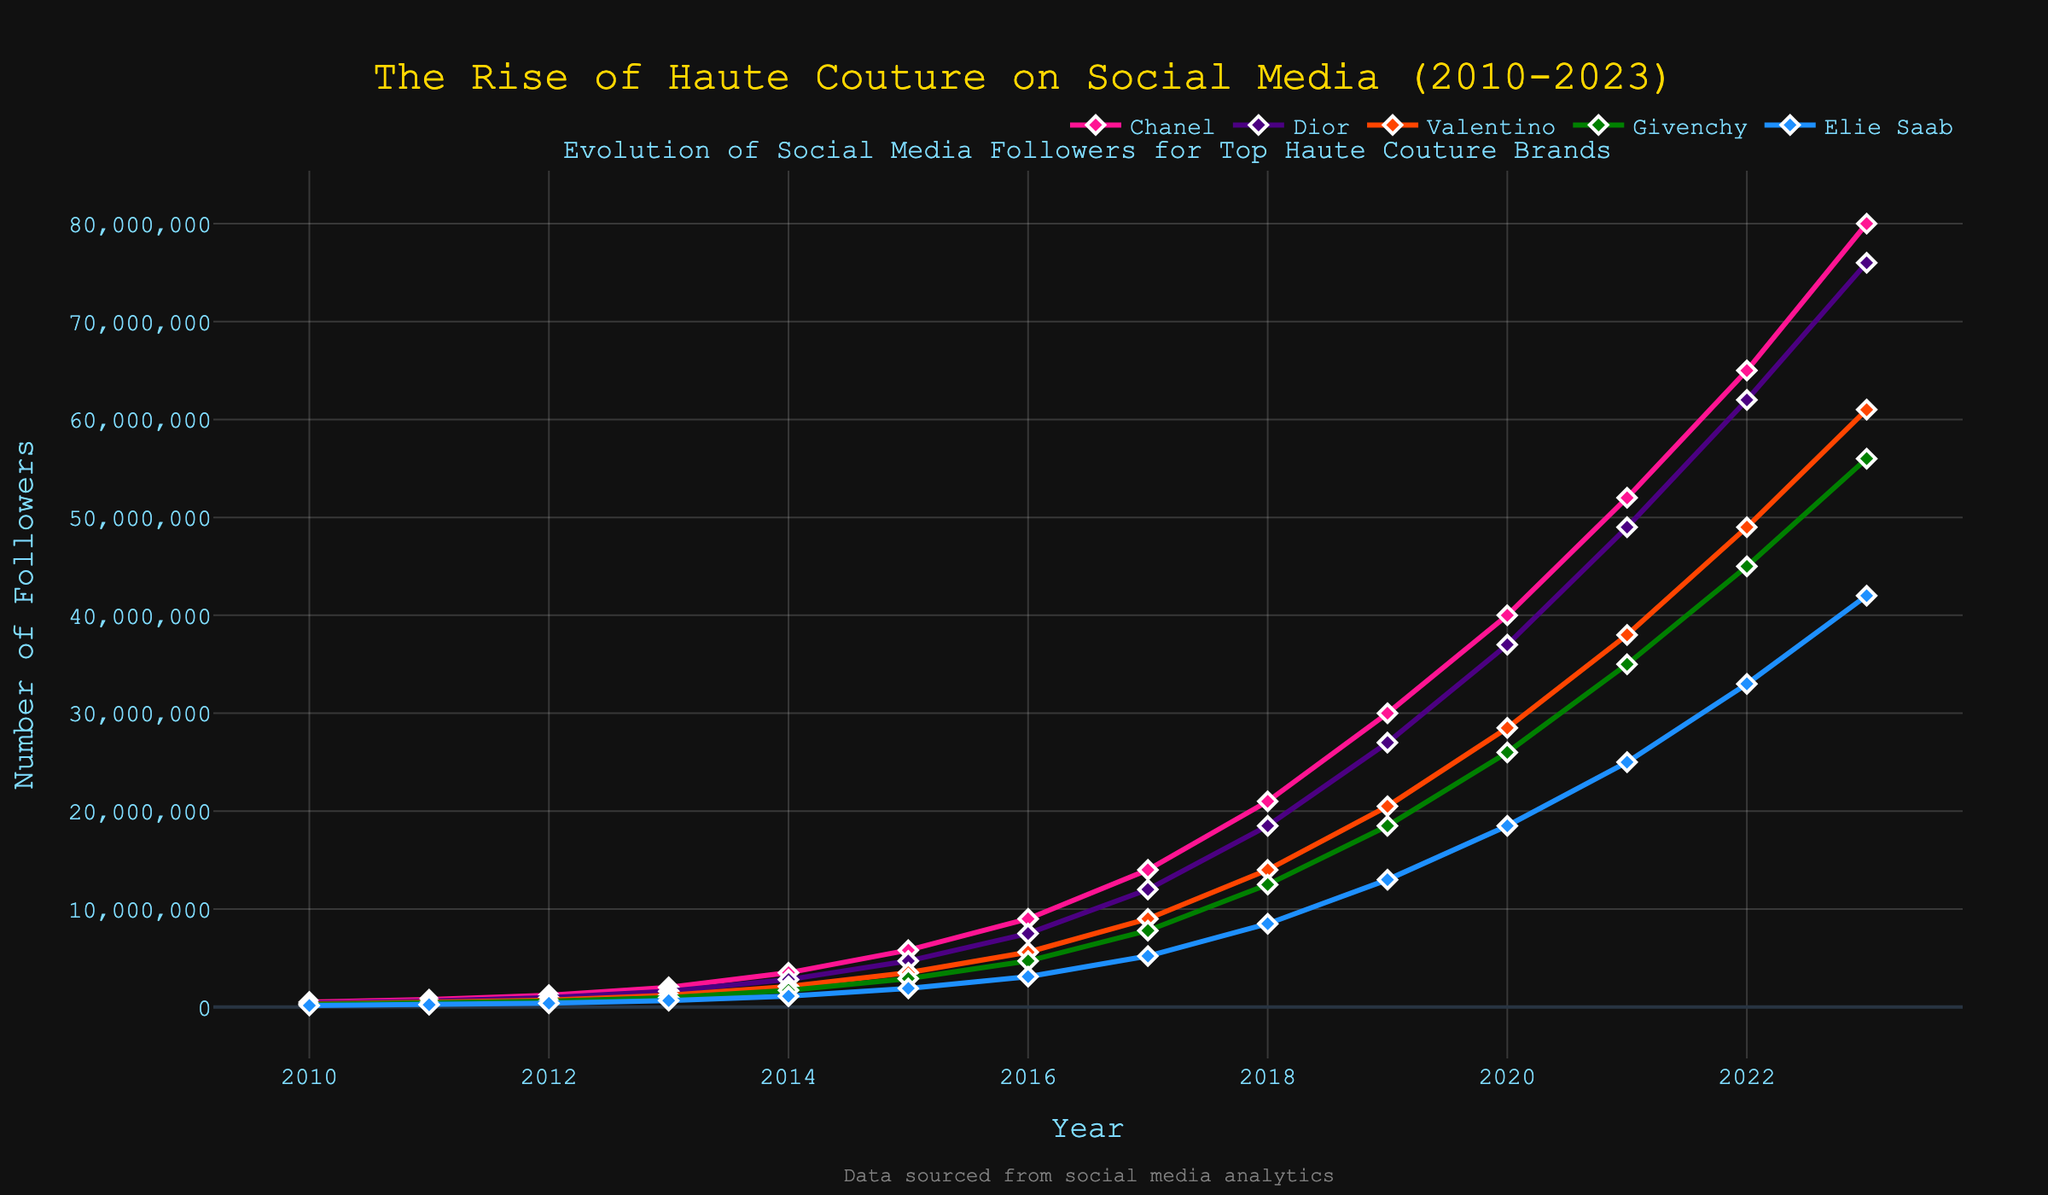How many followers did Chanel gain from 2010 to 2023? To find this, subtract Chanel's followers in 2010 from its followers in 2023: 80,000,000 - 500,000 = 79,500,000.
Answer: 79,500,000 Which brand had the highest number of followers in 2023? Check the follower count for each brand in 2023 and identify the highest number, which is 80,000,000 for Chanel.
Answer: Chanel Between which consecutive years did Dior experience the largest growth in followers? Calculate the yearly increase for Dior and compare them: 
2011-2010: 600,000 - 400,000 = 200,000
2012-2011: 950,000 - 600,000 = 350,000
2013-2012: 1,600,000 - 950,000 = 650,000
2014-2013: 2,800,000 - 1,600,000 = 1,200,000
2015-2014: 4,700,000 - 2,800,000 = 1,900,000
2016-2015: 7,500,000 - 4,700,000 = 2,800,000
2017-2016: 12,000,000 - 7,500,000 = 4,500,000
2018-2017: 18,500,000 - 12,000,000 = 6,500,000
2019-2018: 27,000,000 - 18,500,000 = 8,500,000
2020-2019: 37,000,000 - 27,000,000 = 10,000,000
2021-2020: 49,000,000 - 37,000,000 = 12,000,000
2022-2021: 62,000,000 - 49,000,000 = 13,000,000
2023-2022: 76,000,000 - 62,000,000 = 14,000,000
The largest growth is between 2022 and 2023, which is 14,000,000.
Answer: 2022-2023 What was the total number of followers for all brands combined in 2015? Sum the follower counts for all brands in 2015: 
Chanel: 5,800,000
Dior: 4,700,000
Valentino: 3,500,000
Givenchy: 2,900,000
Elie Saab: 1,900,000
Total = 5,800,000 + 4,700,000 + 3,500,000 + 2,900,000 + 1,900,000 = 18,800,000.
Answer: 18,800,000 How many more followers did Givenchy have in 2020 compared to 2013? Subtract Givenchy’s followers in 2013 from its followers in 2020: 
26,000,000 - 950,000 = 25,050,000.
Answer: 25,050,000 In which year did Elie Saab reach 10,000,000 followers? Identify the first year in the timeline when Elie Saab's followers exceed 10,000,000. In 2017, Elie Saab reached 5,200,000, but in 2018, it reached 8,500,000, so it exceeded 10,000,000 thereafter. The exact year is tracked in 2019 with 13,000,000 followers.
Answer: 2019 What is the average number of followers for Valentino over the years 2017-2020? Calculate the average followers for Valentino from 2017 to 2020: 
(9,000,000 + 14,000,000 + 20,500,000 + 28,500,000) / 4 = 72,000,000 / 4 = 18,000,000.
Answer: 18,000,000 Compare the growth trend of Chanel and Dior from 2016 to 2023. Which brand experienced higher growth? Calculate the total increase in followers for each brand from 2016 to 2023:
Chanel: 80,000,000 - 9,000,000 = 71,000,000
Dior: 76,000,000 - 7,500,000 = 68,500,000.
Chanel experienced a higher growth of 71,000,000 compared to Dior’s 68,500,000.
Answer: Chanel How many followers did Elie Saab have in 2011, and how does this compare to Valentino in the same year? Elie Saab had 230,000 followers in 2011, while Valentino had 450,000 followers. Comparing these values, Valentino had 450,000 - 230,000 = 220,000 more followers than Elie Saab.
Answer: 220,000 more followers 